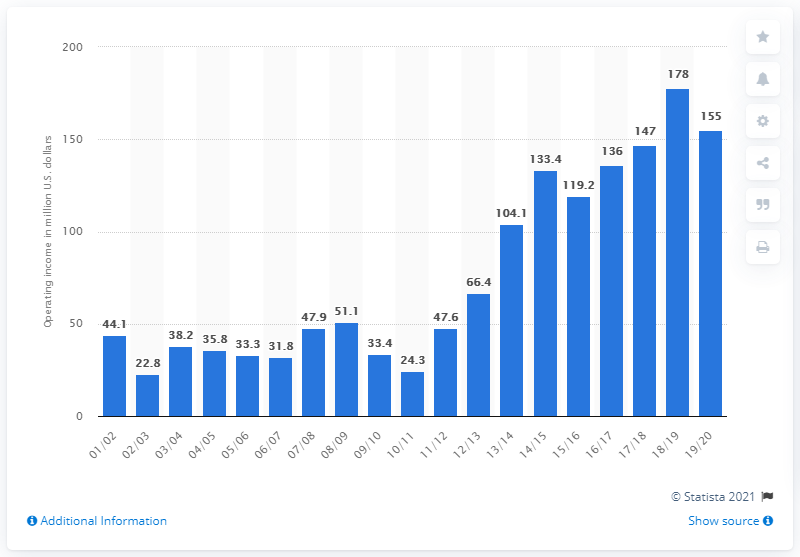Give some essential details in this illustration. The operating income of the Los Angeles Lakers during the 2019/20 season was 155 million dollars. 